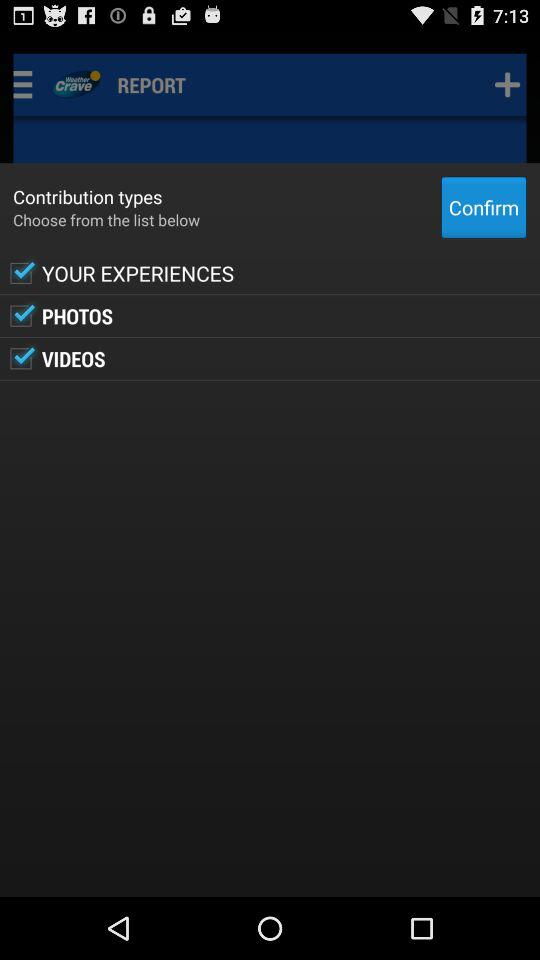Which options are selected in "Contribution types"? The selected options in "Contribution types" are "YOUR EXPERIENCES", "PHOTOS" and "VIDEOS". 